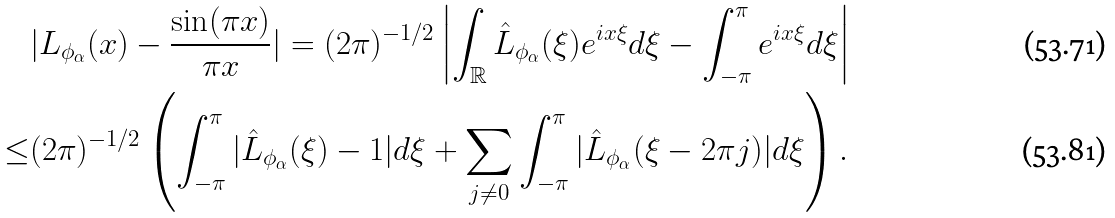Convert formula to latex. <formula><loc_0><loc_0><loc_500><loc_500>& | L _ { \phi _ { \alpha } } ( x ) - \frac { \sin ( \pi x ) } { \pi x } | = ( 2 \pi ) ^ { - 1 / 2 } \left | \int _ { \mathbb { R } } \hat { L } _ { \phi _ { \alpha } } ( \xi ) e ^ { i x \xi } d \xi - \int _ { - \pi } ^ { \pi } e ^ { i x \xi } d \xi \right | \\ \leq & ( 2 \pi ) ^ { - 1 / 2 } \left ( \int _ { - \pi } ^ { \pi } | \hat { L } _ { \phi _ { \alpha } } ( \xi ) - 1 | d \xi + \sum _ { j \neq 0 } \int _ { - \pi } ^ { \pi } | \hat { L } _ { \phi _ { \alpha } } ( \xi - 2 \pi j ) | d \xi \right ) .</formula> 